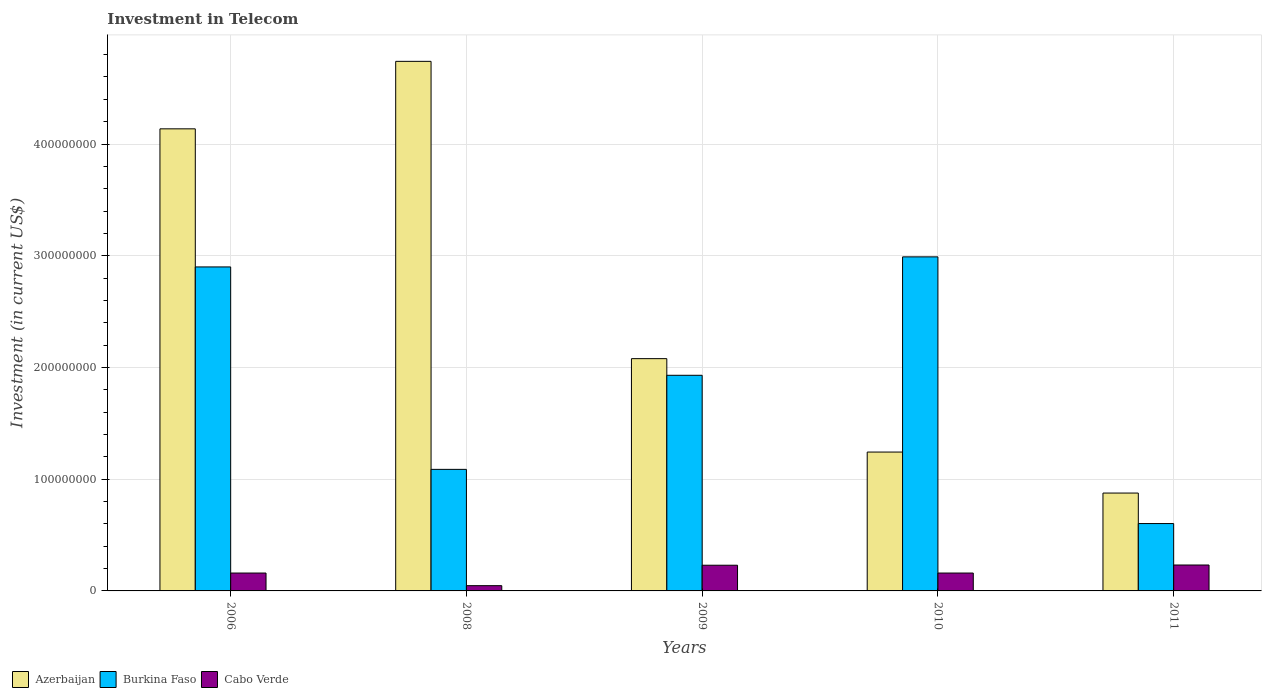How many different coloured bars are there?
Offer a terse response. 3. How many groups of bars are there?
Offer a terse response. 5. Are the number of bars on each tick of the X-axis equal?
Your answer should be compact. Yes. How many bars are there on the 4th tick from the left?
Keep it short and to the point. 3. What is the amount invested in telecom in Burkina Faso in 2011?
Your response must be concise. 6.03e+07. Across all years, what is the maximum amount invested in telecom in Azerbaijan?
Provide a succinct answer. 4.74e+08. Across all years, what is the minimum amount invested in telecom in Azerbaijan?
Your answer should be very brief. 8.76e+07. In which year was the amount invested in telecom in Cabo Verde maximum?
Your response must be concise. 2011. What is the total amount invested in telecom in Cabo Verde in the graph?
Your answer should be very brief. 8.29e+07. What is the difference between the amount invested in telecom in Burkina Faso in 2006 and that in 2009?
Provide a short and direct response. 9.70e+07. What is the difference between the amount invested in telecom in Burkina Faso in 2008 and the amount invested in telecom in Azerbaijan in 2010?
Your answer should be compact. -1.55e+07. What is the average amount invested in telecom in Cabo Verde per year?
Your answer should be compact. 1.66e+07. In the year 2010, what is the difference between the amount invested in telecom in Azerbaijan and amount invested in telecom in Burkina Faso?
Your answer should be very brief. -1.75e+08. In how many years, is the amount invested in telecom in Azerbaijan greater than 440000000 US$?
Your response must be concise. 1. What is the ratio of the amount invested in telecom in Cabo Verde in 2008 to that in 2009?
Your answer should be compact. 0.2. Is the amount invested in telecom in Burkina Faso in 2008 less than that in 2010?
Offer a very short reply. Yes. Is the difference between the amount invested in telecom in Azerbaijan in 2006 and 2011 greater than the difference between the amount invested in telecom in Burkina Faso in 2006 and 2011?
Give a very brief answer. Yes. What is the difference between the highest and the second highest amount invested in telecom in Burkina Faso?
Give a very brief answer. 9.00e+06. What is the difference between the highest and the lowest amount invested in telecom in Cabo Verde?
Your response must be concise. 1.85e+07. In how many years, is the amount invested in telecom in Cabo Verde greater than the average amount invested in telecom in Cabo Verde taken over all years?
Keep it short and to the point. 2. What does the 1st bar from the left in 2010 represents?
Provide a short and direct response. Azerbaijan. What does the 1st bar from the right in 2011 represents?
Provide a short and direct response. Cabo Verde. How many bars are there?
Make the answer very short. 15. Where does the legend appear in the graph?
Keep it short and to the point. Bottom left. How many legend labels are there?
Offer a terse response. 3. How are the legend labels stacked?
Provide a succinct answer. Horizontal. What is the title of the graph?
Offer a terse response. Investment in Telecom. What is the label or title of the Y-axis?
Provide a short and direct response. Investment (in current US$). What is the Investment (in current US$) in Azerbaijan in 2006?
Your answer should be very brief. 4.14e+08. What is the Investment (in current US$) in Burkina Faso in 2006?
Make the answer very short. 2.90e+08. What is the Investment (in current US$) in Cabo Verde in 2006?
Your answer should be very brief. 1.60e+07. What is the Investment (in current US$) in Azerbaijan in 2008?
Provide a short and direct response. 4.74e+08. What is the Investment (in current US$) in Burkina Faso in 2008?
Ensure brevity in your answer.  1.09e+08. What is the Investment (in current US$) of Cabo Verde in 2008?
Offer a terse response. 4.70e+06. What is the Investment (in current US$) of Azerbaijan in 2009?
Your answer should be very brief. 2.08e+08. What is the Investment (in current US$) of Burkina Faso in 2009?
Make the answer very short. 1.93e+08. What is the Investment (in current US$) of Cabo Verde in 2009?
Ensure brevity in your answer.  2.30e+07. What is the Investment (in current US$) in Azerbaijan in 2010?
Provide a short and direct response. 1.24e+08. What is the Investment (in current US$) in Burkina Faso in 2010?
Offer a very short reply. 2.99e+08. What is the Investment (in current US$) of Cabo Verde in 2010?
Ensure brevity in your answer.  1.60e+07. What is the Investment (in current US$) of Azerbaijan in 2011?
Your answer should be compact. 8.76e+07. What is the Investment (in current US$) in Burkina Faso in 2011?
Your answer should be compact. 6.03e+07. What is the Investment (in current US$) of Cabo Verde in 2011?
Provide a short and direct response. 2.32e+07. Across all years, what is the maximum Investment (in current US$) in Azerbaijan?
Make the answer very short. 4.74e+08. Across all years, what is the maximum Investment (in current US$) in Burkina Faso?
Provide a short and direct response. 2.99e+08. Across all years, what is the maximum Investment (in current US$) of Cabo Verde?
Ensure brevity in your answer.  2.32e+07. Across all years, what is the minimum Investment (in current US$) of Azerbaijan?
Offer a terse response. 8.76e+07. Across all years, what is the minimum Investment (in current US$) in Burkina Faso?
Keep it short and to the point. 6.03e+07. Across all years, what is the minimum Investment (in current US$) of Cabo Verde?
Provide a short and direct response. 4.70e+06. What is the total Investment (in current US$) of Azerbaijan in the graph?
Provide a succinct answer. 1.31e+09. What is the total Investment (in current US$) of Burkina Faso in the graph?
Offer a terse response. 9.51e+08. What is the total Investment (in current US$) in Cabo Verde in the graph?
Ensure brevity in your answer.  8.29e+07. What is the difference between the Investment (in current US$) in Azerbaijan in 2006 and that in 2008?
Offer a terse response. -6.04e+07. What is the difference between the Investment (in current US$) of Burkina Faso in 2006 and that in 2008?
Your response must be concise. 1.81e+08. What is the difference between the Investment (in current US$) of Cabo Verde in 2006 and that in 2008?
Your response must be concise. 1.13e+07. What is the difference between the Investment (in current US$) of Azerbaijan in 2006 and that in 2009?
Give a very brief answer. 2.06e+08. What is the difference between the Investment (in current US$) of Burkina Faso in 2006 and that in 2009?
Give a very brief answer. 9.70e+07. What is the difference between the Investment (in current US$) in Cabo Verde in 2006 and that in 2009?
Your response must be concise. -7.00e+06. What is the difference between the Investment (in current US$) of Azerbaijan in 2006 and that in 2010?
Your response must be concise. 2.89e+08. What is the difference between the Investment (in current US$) in Burkina Faso in 2006 and that in 2010?
Offer a terse response. -9.00e+06. What is the difference between the Investment (in current US$) in Cabo Verde in 2006 and that in 2010?
Give a very brief answer. 0. What is the difference between the Investment (in current US$) in Azerbaijan in 2006 and that in 2011?
Make the answer very short. 3.26e+08. What is the difference between the Investment (in current US$) of Burkina Faso in 2006 and that in 2011?
Give a very brief answer. 2.30e+08. What is the difference between the Investment (in current US$) in Cabo Verde in 2006 and that in 2011?
Your response must be concise. -7.20e+06. What is the difference between the Investment (in current US$) of Azerbaijan in 2008 and that in 2009?
Keep it short and to the point. 2.66e+08. What is the difference between the Investment (in current US$) in Burkina Faso in 2008 and that in 2009?
Keep it short and to the point. -8.42e+07. What is the difference between the Investment (in current US$) of Cabo Verde in 2008 and that in 2009?
Offer a very short reply. -1.83e+07. What is the difference between the Investment (in current US$) of Azerbaijan in 2008 and that in 2010?
Ensure brevity in your answer.  3.50e+08. What is the difference between the Investment (in current US$) in Burkina Faso in 2008 and that in 2010?
Your response must be concise. -1.90e+08. What is the difference between the Investment (in current US$) in Cabo Verde in 2008 and that in 2010?
Offer a terse response. -1.13e+07. What is the difference between the Investment (in current US$) of Azerbaijan in 2008 and that in 2011?
Offer a terse response. 3.86e+08. What is the difference between the Investment (in current US$) in Burkina Faso in 2008 and that in 2011?
Ensure brevity in your answer.  4.85e+07. What is the difference between the Investment (in current US$) in Cabo Verde in 2008 and that in 2011?
Keep it short and to the point. -1.85e+07. What is the difference between the Investment (in current US$) of Azerbaijan in 2009 and that in 2010?
Offer a terse response. 8.36e+07. What is the difference between the Investment (in current US$) of Burkina Faso in 2009 and that in 2010?
Your response must be concise. -1.06e+08. What is the difference between the Investment (in current US$) in Cabo Verde in 2009 and that in 2010?
Provide a short and direct response. 7.00e+06. What is the difference between the Investment (in current US$) of Azerbaijan in 2009 and that in 2011?
Provide a short and direct response. 1.20e+08. What is the difference between the Investment (in current US$) of Burkina Faso in 2009 and that in 2011?
Your answer should be very brief. 1.33e+08. What is the difference between the Investment (in current US$) of Cabo Verde in 2009 and that in 2011?
Offer a terse response. -2.00e+05. What is the difference between the Investment (in current US$) of Azerbaijan in 2010 and that in 2011?
Ensure brevity in your answer.  3.67e+07. What is the difference between the Investment (in current US$) of Burkina Faso in 2010 and that in 2011?
Provide a short and direct response. 2.39e+08. What is the difference between the Investment (in current US$) of Cabo Verde in 2010 and that in 2011?
Keep it short and to the point. -7.20e+06. What is the difference between the Investment (in current US$) in Azerbaijan in 2006 and the Investment (in current US$) in Burkina Faso in 2008?
Provide a short and direct response. 3.05e+08. What is the difference between the Investment (in current US$) in Azerbaijan in 2006 and the Investment (in current US$) in Cabo Verde in 2008?
Offer a terse response. 4.09e+08. What is the difference between the Investment (in current US$) of Burkina Faso in 2006 and the Investment (in current US$) of Cabo Verde in 2008?
Your response must be concise. 2.85e+08. What is the difference between the Investment (in current US$) of Azerbaijan in 2006 and the Investment (in current US$) of Burkina Faso in 2009?
Make the answer very short. 2.21e+08. What is the difference between the Investment (in current US$) in Azerbaijan in 2006 and the Investment (in current US$) in Cabo Verde in 2009?
Give a very brief answer. 3.91e+08. What is the difference between the Investment (in current US$) in Burkina Faso in 2006 and the Investment (in current US$) in Cabo Verde in 2009?
Provide a succinct answer. 2.67e+08. What is the difference between the Investment (in current US$) of Azerbaijan in 2006 and the Investment (in current US$) of Burkina Faso in 2010?
Offer a terse response. 1.15e+08. What is the difference between the Investment (in current US$) in Azerbaijan in 2006 and the Investment (in current US$) in Cabo Verde in 2010?
Your answer should be very brief. 3.98e+08. What is the difference between the Investment (in current US$) of Burkina Faso in 2006 and the Investment (in current US$) of Cabo Verde in 2010?
Keep it short and to the point. 2.74e+08. What is the difference between the Investment (in current US$) in Azerbaijan in 2006 and the Investment (in current US$) in Burkina Faso in 2011?
Provide a succinct answer. 3.53e+08. What is the difference between the Investment (in current US$) in Azerbaijan in 2006 and the Investment (in current US$) in Cabo Verde in 2011?
Your answer should be very brief. 3.90e+08. What is the difference between the Investment (in current US$) in Burkina Faso in 2006 and the Investment (in current US$) in Cabo Verde in 2011?
Offer a very short reply. 2.67e+08. What is the difference between the Investment (in current US$) of Azerbaijan in 2008 and the Investment (in current US$) of Burkina Faso in 2009?
Make the answer very short. 2.81e+08. What is the difference between the Investment (in current US$) in Azerbaijan in 2008 and the Investment (in current US$) in Cabo Verde in 2009?
Give a very brief answer. 4.51e+08. What is the difference between the Investment (in current US$) in Burkina Faso in 2008 and the Investment (in current US$) in Cabo Verde in 2009?
Your answer should be very brief. 8.58e+07. What is the difference between the Investment (in current US$) of Azerbaijan in 2008 and the Investment (in current US$) of Burkina Faso in 2010?
Provide a short and direct response. 1.75e+08. What is the difference between the Investment (in current US$) in Azerbaijan in 2008 and the Investment (in current US$) in Cabo Verde in 2010?
Keep it short and to the point. 4.58e+08. What is the difference between the Investment (in current US$) in Burkina Faso in 2008 and the Investment (in current US$) in Cabo Verde in 2010?
Make the answer very short. 9.28e+07. What is the difference between the Investment (in current US$) in Azerbaijan in 2008 and the Investment (in current US$) in Burkina Faso in 2011?
Offer a very short reply. 4.14e+08. What is the difference between the Investment (in current US$) of Azerbaijan in 2008 and the Investment (in current US$) of Cabo Verde in 2011?
Your answer should be compact. 4.51e+08. What is the difference between the Investment (in current US$) in Burkina Faso in 2008 and the Investment (in current US$) in Cabo Verde in 2011?
Your answer should be very brief. 8.56e+07. What is the difference between the Investment (in current US$) in Azerbaijan in 2009 and the Investment (in current US$) in Burkina Faso in 2010?
Offer a very short reply. -9.11e+07. What is the difference between the Investment (in current US$) of Azerbaijan in 2009 and the Investment (in current US$) of Cabo Verde in 2010?
Offer a terse response. 1.92e+08. What is the difference between the Investment (in current US$) of Burkina Faso in 2009 and the Investment (in current US$) of Cabo Verde in 2010?
Keep it short and to the point. 1.77e+08. What is the difference between the Investment (in current US$) of Azerbaijan in 2009 and the Investment (in current US$) of Burkina Faso in 2011?
Keep it short and to the point. 1.48e+08. What is the difference between the Investment (in current US$) in Azerbaijan in 2009 and the Investment (in current US$) in Cabo Verde in 2011?
Ensure brevity in your answer.  1.85e+08. What is the difference between the Investment (in current US$) of Burkina Faso in 2009 and the Investment (in current US$) of Cabo Verde in 2011?
Your response must be concise. 1.70e+08. What is the difference between the Investment (in current US$) in Azerbaijan in 2010 and the Investment (in current US$) in Burkina Faso in 2011?
Offer a very short reply. 6.40e+07. What is the difference between the Investment (in current US$) of Azerbaijan in 2010 and the Investment (in current US$) of Cabo Verde in 2011?
Your response must be concise. 1.01e+08. What is the difference between the Investment (in current US$) in Burkina Faso in 2010 and the Investment (in current US$) in Cabo Verde in 2011?
Provide a short and direct response. 2.76e+08. What is the average Investment (in current US$) in Azerbaijan per year?
Give a very brief answer. 2.61e+08. What is the average Investment (in current US$) in Burkina Faso per year?
Give a very brief answer. 1.90e+08. What is the average Investment (in current US$) in Cabo Verde per year?
Give a very brief answer. 1.66e+07. In the year 2006, what is the difference between the Investment (in current US$) of Azerbaijan and Investment (in current US$) of Burkina Faso?
Your response must be concise. 1.24e+08. In the year 2006, what is the difference between the Investment (in current US$) of Azerbaijan and Investment (in current US$) of Cabo Verde?
Your answer should be compact. 3.98e+08. In the year 2006, what is the difference between the Investment (in current US$) of Burkina Faso and Investment (in current US$) of Cabo Verde?
Offer a very short reply. 2.74e+08. In the year 2008, what is the difference between the Investment (in current US$) in Azerbaijan and Investment (in current US$) in Burkina Faso?
Your answer should be compact. 3.65e+08. In the year 2008, what is the difference between the Investment (in current US$) in Azerbaijan and Investment (in current US$) in Cabo Verde?
Offer a very short reply. 4.69e+08. In the year 2008, what is the difference between the Investment (in current US$) in Burkina Faso and Investment (in current US$) in Cabo Verde?
Ensure brevity in your answer.  1.04e+08. In the year 2009, what is the difference between the Investment (in current US$) of Azerbaijan and Investment (in current US$) of Burkina Faso?
Make the answer very short. 1.49e+07. In the year 2009, what is the difference between the Investment (in current US$) of Azerbaijan and Investment (in current US$) of Cabo Verde?
Your response must be concise. 1.85e+08. In the year 2009, what is the difference between the Investment (in current US$) in Burkina Faso and Investment (in current US$) in Cabo Verde?
Keep it short and to the point. 1.70e+08. In the year 2010, what is the difference between the Investment (in current US$) in Azerbaijan and Investment (in current US$) in Burkina Faso?
Ensure brevity in your answer.  -1.75e+08. In the year 2010, what is the difference between the Investment (in current US$) of Azerbaijan and Investment (in current US$) of Cabo Verde?
Give a very brief answer. 1.08e+08. In the year 2010, what is the difference between the Investment (in current US$) of Burkina Faso and Investment (in current US$) of Cabo Verde?
Offer a terse response. 2.83e+08. In the year 2011, what is the difference between the Investment (in current US$) in Azerbaijan and Investment (in current US$) in Burkina Faso?
Make the answer very short. 2.73e+07. In the year 2011, what is the difference between the Investment (in current US$) of Azerbaijan and Investment (in current US$) of Cabo Verde?
Offer a very short reply. 6.44e+07. In the year 2011, what is the difference between the Investment (in current US$) of Burkina Faso and Investment (in current US$) of Cabo Verde?
Your answer should be very brief. 3.71e+07. What is the ratio of the Investment (in current US$) of Azerbaijan in 2006 to that in 2008?
Ensure brevity in your answer.  0.87. What is the ratio of the Investment (in current US$) in Burkina Faso in 2006 to that in 2008?
Provide a succinct answer. 2.67. What is the ratio of the Investment (in current US$) in Cabo Verde in 2006 to that in 2008?
Offer a terse response. 3.4. What is the ratio of the Investment (in current US$) in Azerbaijan in 2006 to that in 2009?
Offer a terse response. 1.99. What is the ratio of the Investment (in current US$) in Burkina Faso in 2006 to that in 2009?
Give a very brief answer. 1.5. What is the ratio of the Investment (in current US$) of Cabo Verde in 2006 to that in 2009?
Provide a short and direct response. 0.7. What is the ratio of the Investment (in current US$) in Azerbaijan in 2006 to that in 2010?
Keep it short and to the point. 3.33. What is the ratio of the Investment (in current US$) of Burkina Faso in 2006 to that in 2010?
Your answer should be very brief. 0.97. What is the ratio of the Investment (in current US$) in Cabo Verde in 2006 to that in 2010?
Ensure brevity in your answer.  1. What is the ratio of the Investment (in current US$) of Azerbaijan in 2006 to that in 2011?
Your answer should be compact. 4.72. What is the ratio of the Investment (in current US$) in Burkina Faso in 2006 to that in 2011?
Offer a terse response. 4.81. What is the ratio of the Investment (in current US$) in Cabo Verde in 2006 to that in 2011?
Keep it short and to the point. 0.69. What is the ratio of the Investment (in current US$) of Azerbaijan in 2008 to that in 2009?
Your answer should be compact. 2.28. What is the ratio of the Investment (in current US$) in Burkina Faso in 2008 to that in 2009?
Your response must be concise. 0.56. What is the ratio of the Investment (in current US$) of Cabo Verde in 2008 to that in 2009?
Offer a terse response. 0.2. What is the ratio of the Investment (in current US$) of Azerbaijan in 2008 to that in 2010?
Your answer should be compact. 3.81. What is the ratio of the Investment (in current US$) of Burkina Faso in 2008 to that in 2010?
Provide a succinct answer. 0.36. What is the ratio of the Investment (in current US$) of Cabo Verde in 2008 to that in 2010?
Make the answer very short. 0.29. What is the ratio of the Investment (in current US$) in Azerbaijan in 2008 to that in 2011?
Offer a very short reply. 5.41. What is the ratio of the Investment (in current US$) of Burkina Faso in 2008 to that in 2011?
Make the answer very short. 1.8. What is the ratio of the Investment (in current US$) in Cabo Verde in 2008 to that in 2011?
Your response must be concise. 0.2. What is the ratio of the Investment (in current US$) of Azerbaijan in 2009 to that in 2010?
Provide a short and direct response. 1.67. What is the ratio of the Investment (in current US$) of Burkina Faso in 2009 to that in 2010?
Give a very brief answer. 0.65. What is the ratio of the Investment (in current US$) of Cabo Verde in 2009 to that in 2010?
Offer a terse response. 1.44. What is the ratio of the Investment (in current US$) of Azerbaijan in 2009 to that in 2011?
Keep it short and to the point. 2.37. What is the ratio of the Investment (in current US$) of Burkina Faso in 2009 to that in 2011?
Your answer should be very brief. 3.2. What is the ratio of the Investment (in current US$) of Cabo Verde in 2009 to that in 2011?
Keep it short and to the point. 0.99. What is the ratio of the Investment (in current US$) of Azerbaijan in 2010 to that in 2011?
Offer a very short reply. 1.42. What is the ratio of the Investment (in current US$) in Burkina Faso in 2010 to that in 2011?
Your response must be concise. 4.96. What is the ratio of the Investment (in current US$) of Cabo Verde in 2010 to that in 2011?
Provide a succinct answer. 0.69. What is the difference between the highest and the second highest Investment (in current US$) in Azerbaijan?
Make the answer very short. 6.04e+07. What is the difference between the highest and the second highest Investment (in current US$) of Burkina Faso?
Ensure brevity in your answer.  9.00e+06. What is the difference between the highest and the lowest Investment (in current US$) of Azerbaijan?
Provide a succinct answer. 3.86e+08. What is the difference between the highest and the lowest Investment (in current US$) in Burkina Faso?
Offer a very short reply. 2.39e+08. What is the difference between the highest and the lowest Investment (in current US$) in Cabo Verde?
Your answer should be very brief. 1.85e+07. 